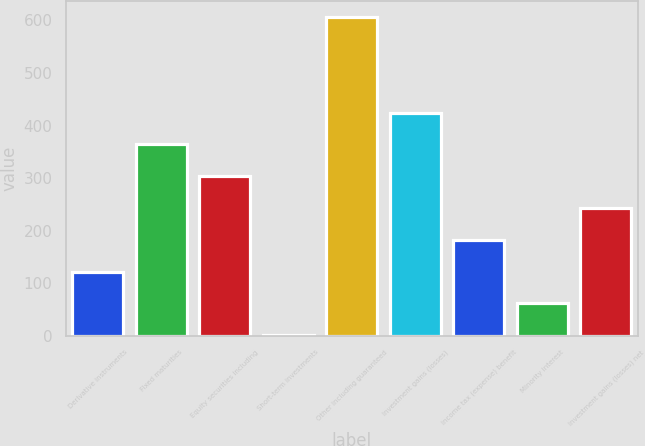<chart> <loc_0><loc_0><loc_500><loc_500><bar_chart><fcel>Derivative instruments<fcel>Fixed maturities<fcel>Equity securities including<fcel>Short-term investments<fcel>Other including guaranteed<fcel>Investment gains (losses)<fcel>Income tax (expense) benefit<fcel>Minority interest<fcel>Investment gains (losses) net<nl><fcel>122.46<fcel>364.38<fcel>303.9<fcel>1.5<fcel>606.3<fcel>424.86<fcel>182.94<fcel>61.98<fcel>243.42<nl></chart> 